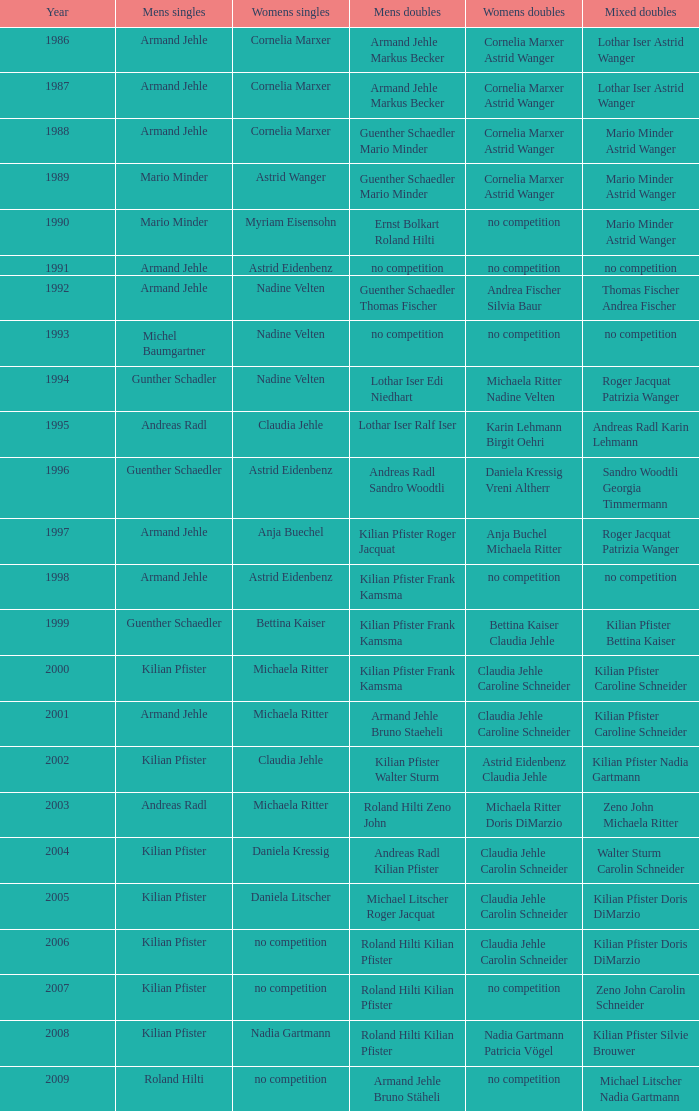During 2006, when the women's singles event had no contest and roland hilti and kilian pfister were in men's doubles, who made up the women's doubles team? Claudia Jehle Carolin Schneider. 